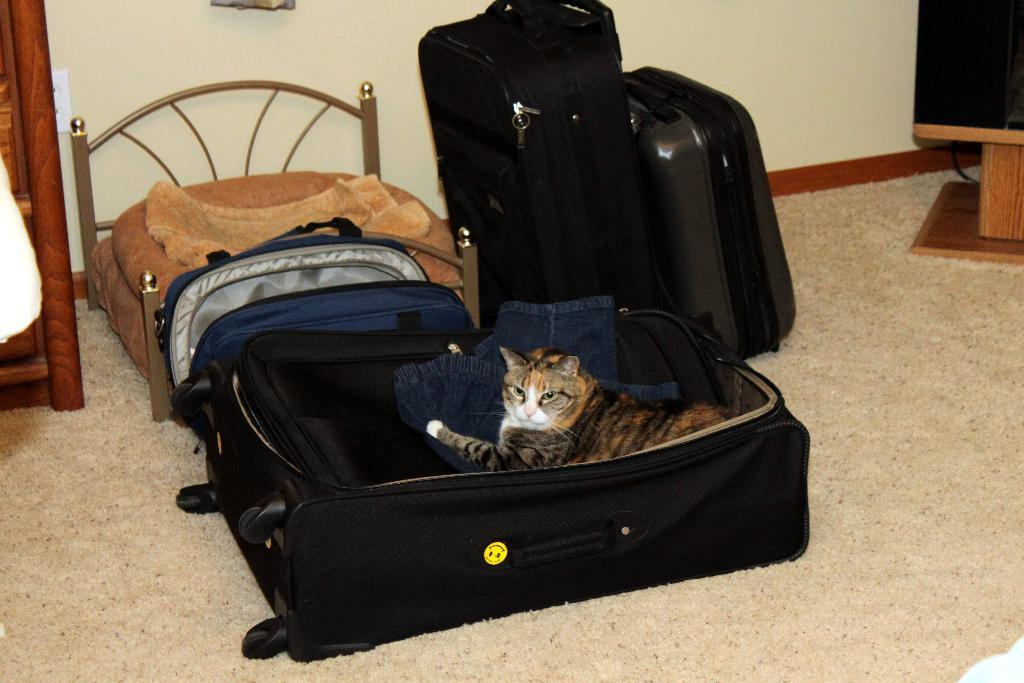What type of animal is present in the image? There is a cat in the image. What is placed on the luggage bag along with the cat? There is a dress placed on the luggage bag. How many luggage bags can be seen in the image? There are additional luggage bags visible in the image. What can be seen in the background of the image? There is a cupboard and a bed in the background of the image. What type of quill is the cat using to write a letter in the image? There is no quill or letter-writing activity present in the image; the cat is simply placed on the luggage bag. 